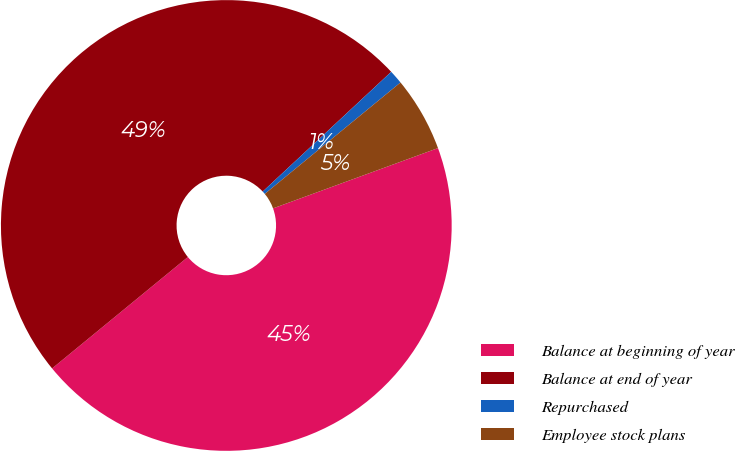<chart> <loc_0><loc_0><loc_500><loc_500><pie_chart><fcel>Balance at beginning of year<fcel>Balance at end of year<fcel>Repurchased<fcel>Employee stock plans<nl><fcel>44.64%<fcel>49.0%<fcel>1.0%<fcel>5.36%<nl></chart> 